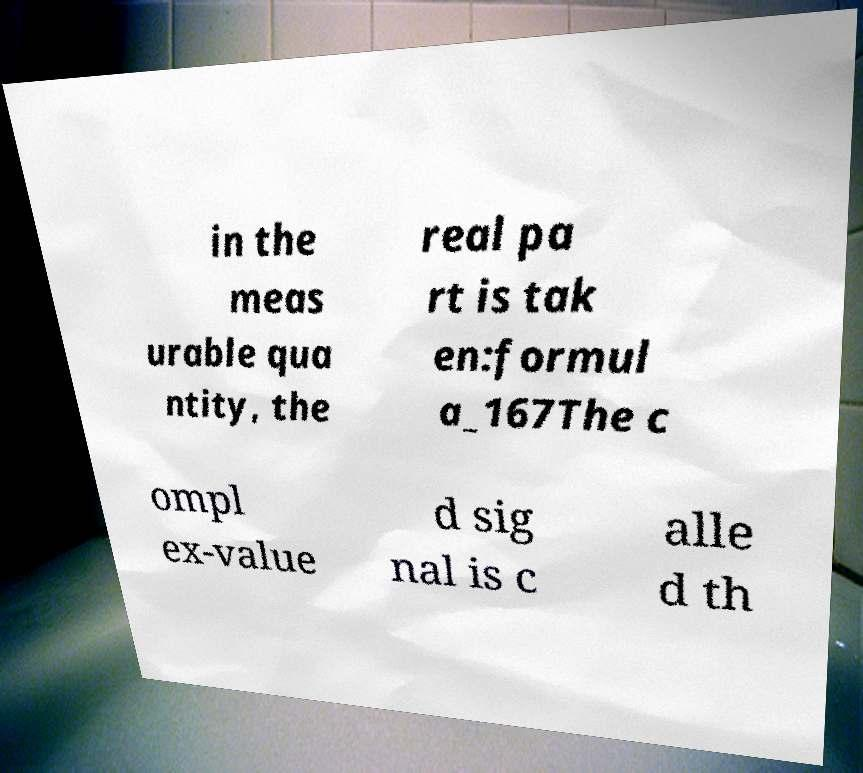There's text embedded in this image that I need extracted. Can you transcribe it verbatim? in the meas urable qua ntity, the real pa rt is tak en:formul a_167The c ompl ex-value d sig nal is c alle d th 